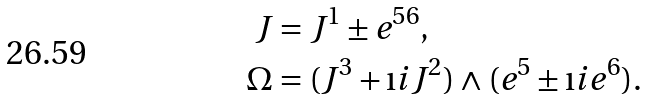<formula> <loc_0><loc_0><loc_500><loc_500>J & = J ^ { 1 } \pm e ^ { 5 6 } , \\ \Omega & = ( J ^ { 3 } + \i i J ^ { 2 } ) \wedge ( e ^ { 5 } \pm \i i e ^ { 6 } ) .</formula> 